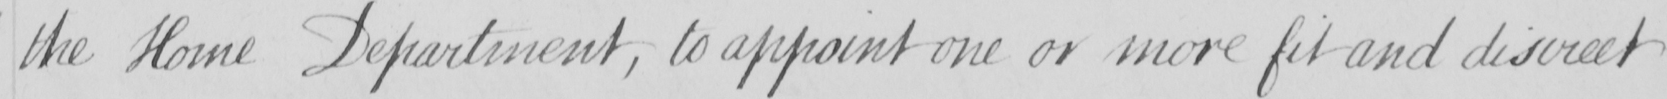Please transcribe the handwritten text in this image. the Home Department , to appoint one or more fit and discreet 